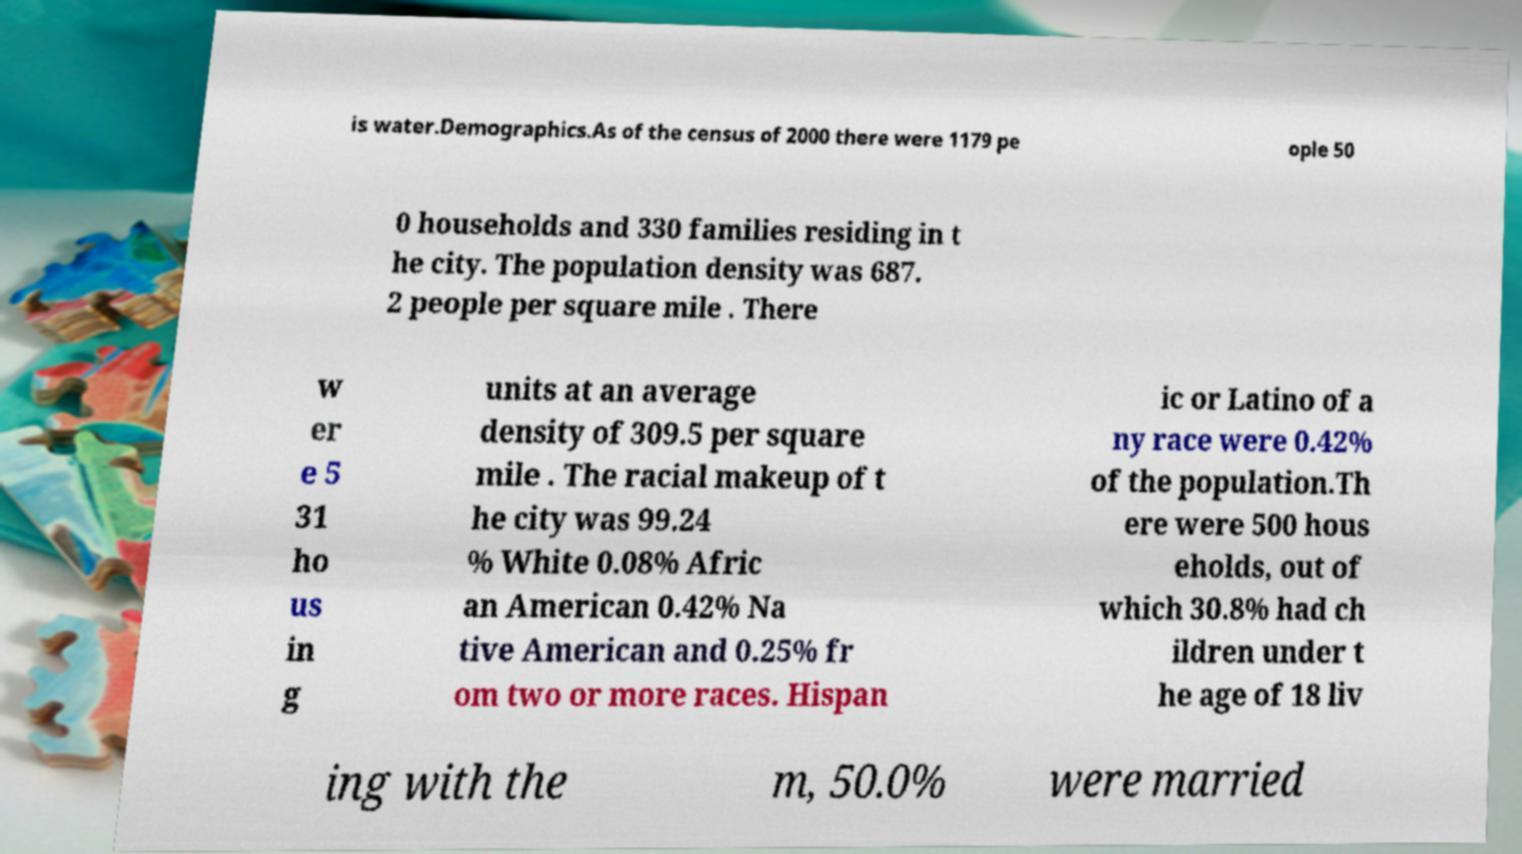Can you read and provide the text displayed in the image?This photo seems to have some interesting text. Can you extract and type it out for me? is water.Demographics.As of the census of 2000 there were 1179 pe ople 50 0 households and 330 families residing in t he city. The population density was 687. 2 people per square mile . There w er e 5 31 ho us in g units at an average density of 309.5 per square mile . The racial makeup of t he city was 99.24 % White 0.08% Afric an American 0.42% Na tive American and 0.25% fr om two or more races. Hispan ic or Latino of a ny race were 0.42% of the population.Th ere were 500 hous eholds, out of which 30.8% had ch ildren under t he age of 18 liv ing with the m, 50.0% were married 